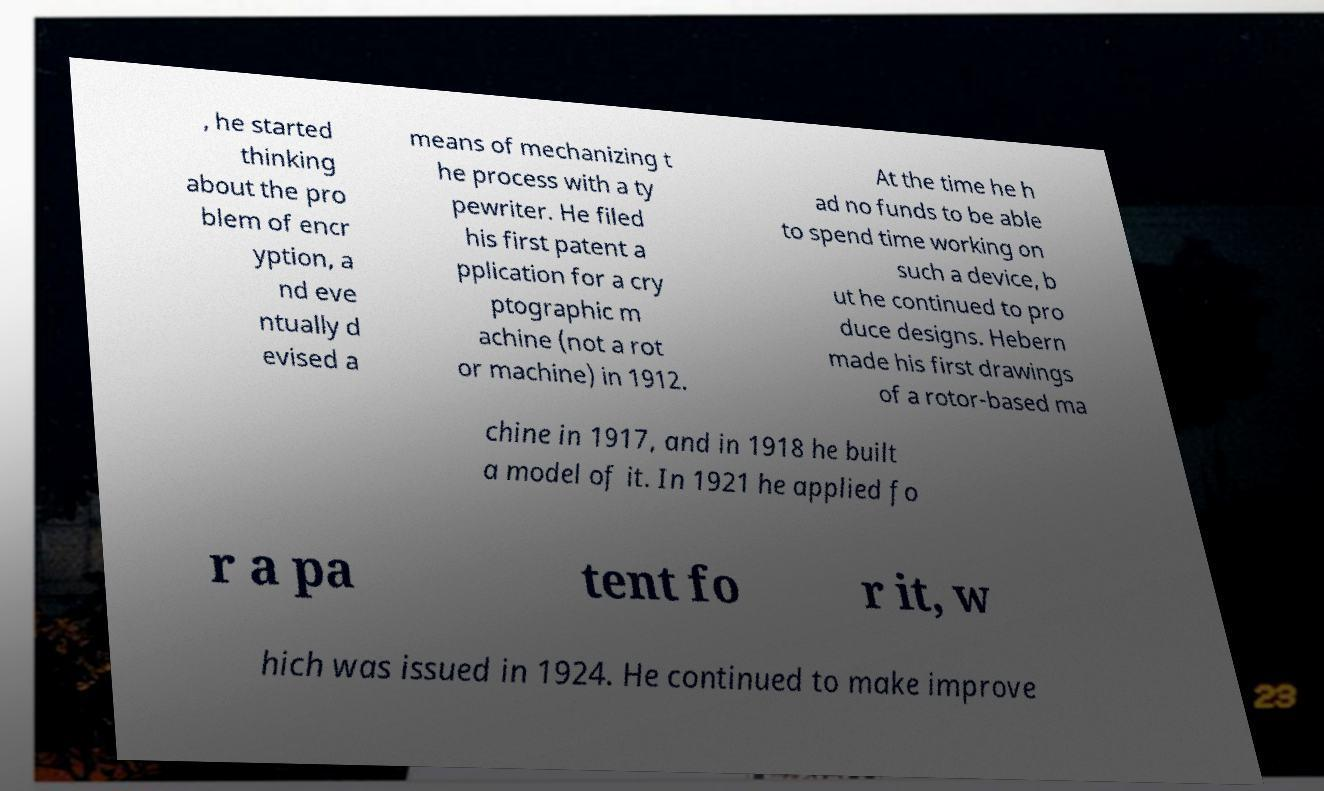I need the written content from this picture converted into text. Can you do that? , he started thinking about the pro blem of encr yption, a nd eve ntually d evised a means of mechanizing t he process with a ty pewriter. He filed his first patent a pplication for a cry ptographic m achine (not a rot or machine) in 1912. At the time he h ad no funds to be able to spend time working on such a device, b ut he continued to pro duce designs. Hebern made his first drawings of a rotor-based ma chine in 1917, and in 1918 he built a model of it. In 1921 he applied fo r a pa tent fo r it, w hich was issued in 1924. He continued to make improve 